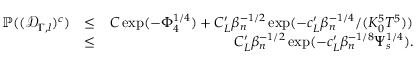Convert formula to latex. <formula><loc_0><loc_0><loc_500><loc_500>\begin{array} { r l r } { \mathbb { P } ( ( \ m a t h s c r { D } _ { \Gamma , l } ) ^ { c } ) } & { \leq } & { C \exp ( - \Phi _ { 4 } ^ { 1 \slash 4 } ) + C _ { L } ^ { \prime } \beta _ { n } ^ { - 1 \slash 2 } \exp ( - c _ { L } ^ { \prime } \beta _ { n } ^ { - 1 \slash 4 } \slash ( K _ { 0 } ^ { 5 } T ^ { 5 } ) ) } \\ & { \leq } & { C _ { L } ^ { \prime } \beta _ { n } ^ { - 1 \slash 2 } \exp ( - c _ { L } ^ { \prime } \beta _ { n } ^ { - 1 \slash 8 } \Psi _ { s } ^ { 1 \slash 4 } ) . } \end{array}</formula> 